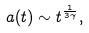Convert formula to latex. <formula><loc_0><loc_0><loc_500><loc_500>a ( t ) \sim t ^ { \frac { 1 } { 3 \gamma } } ,</formula> 